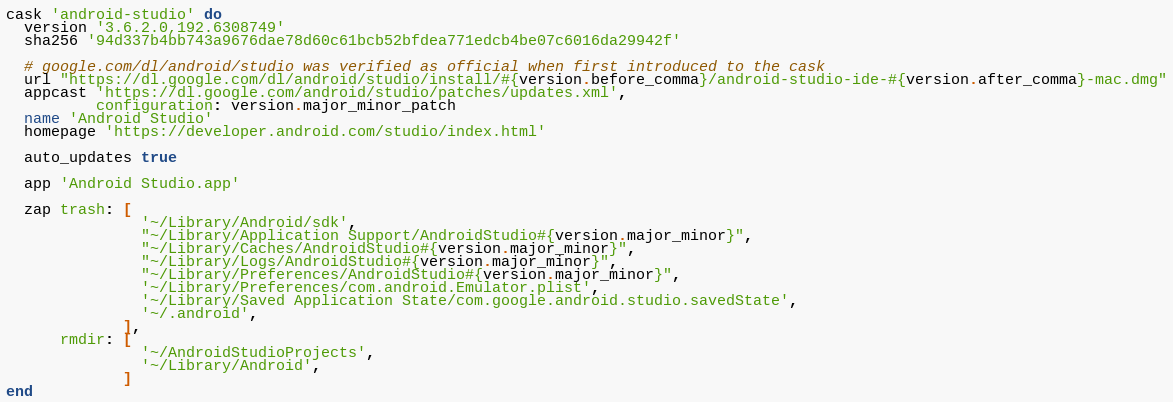Convert code to text. <code><loc_0><loc_0><loc_500><loc_500><_Ruby_>cask 'android-studio' do
  version '3.6.2.0,192.6308749'
  sha256 '94d337b4bb743a9676dae78d60c61bcb52bfdea771edcb4be07c6016da29942f'

  # google.com/dl/android/studio was verified as official when first introduced to the cask
  url "https://dl.google.com/dl/android/studio/install/#{version.before_comma}/android-studio-ide-#{version.after_comma}-mac.dmg"
  appcast 'https://dl.google.com/android/studio/patches/updates.xml',
          configuration: version.major_minor_patch
  name 'Android Studio'
  homepage 'https://developer.android.com/studio/index.html'

  auto_updates true

  app 'Android Studio.app'

  zap trash: [
               '~/Library/Android/sdk',
               "~/Library/Application Support/AndroidStudio#{version.major_minor}",
               "~/Library/Caches/AndroidStudio#{version.major_minor}",
               "~/Library/Logs/AndroidStudio#{version.major_minor}",
               "~/Library/Preferences/AndroidStudio#{version.major_minor}",
               '~/Library/Preferences/com.android.Emulator.plist',
               '~/Library/Saved Application State/com.google.android.studio.savedState',
               '~/.android',
             ],
      rmdir: [
               '~/AndroidStudioProjects',
               '~/Library/Android',
             ]
end
</code> 